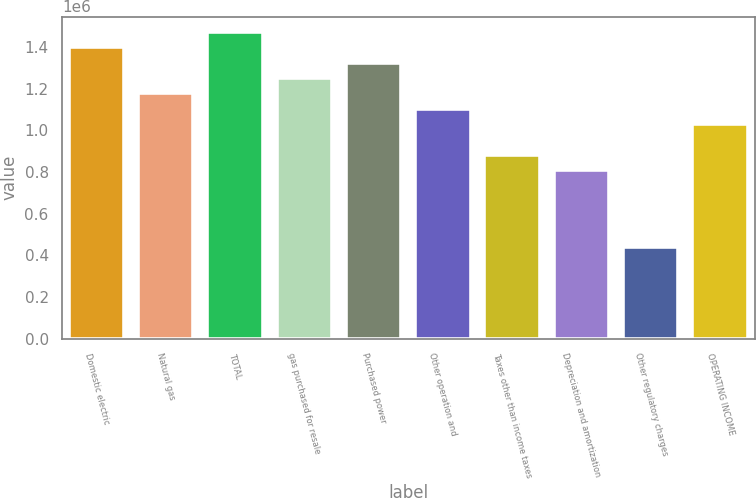Convert chart to OTSL. <chart><loc_0><loc_0><loc_500><loc_500><bar_chart><fcel>Domestic electric<fcel>Natural gas<fcel>TOTAL<fcel>gas purchased for resale<fcel>Purchased power<fcel>Other operation and<fcel>Taxes other than income taxes<fcel>Depreciation and amortization<fcel>Other regulatory charges<fcel>OPERATING INCOME<nl><fcel>1.39791e+06<fcel>1.17723e+06<fcel>1.47147e+06<fcel>1.25079e+06<fcel>1.32435e+06<fcel>1.10367e+06<fcel>882988<fcel>809428<fcel>441629<fcel>1.03011e+06<nl></chart> 